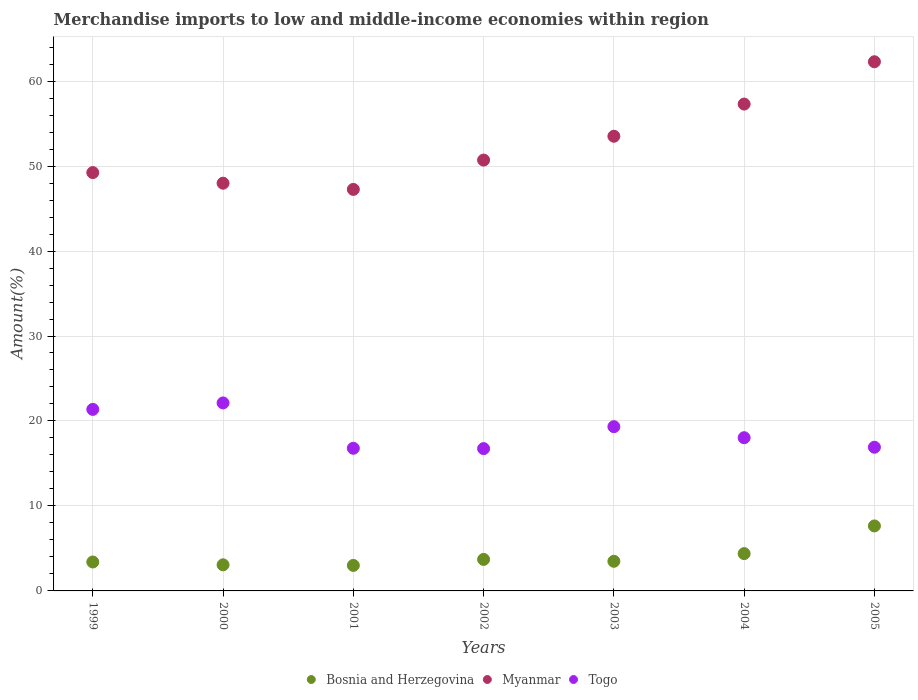How many different coloured dotlines are there?
Offer a terse response. 3. Is the number of dotlines equal to the number of legend labels?
Your response must be concise. Yes. What is the percentage of amount earned from merchandise imports in Bosnia and Herzegovina in 2000?
Give a very brief answer. 3.07. Across all years, what is the maximum percentage of amount earned from merchandise imports in Myanmar?
Give a very brief answer. 62.27. Across all years, what is the minimum percentage of amount earned from merchandise imports in Togo?
Offer a terse response. 16.75. In which year was the percentage of amount earned from merchandise imports in Bosnia and Herzegovina maximum?
Make the answer very short. 2005. In which year was the percentage of amount earned from merchandise imports in Togo minimum?
Your answer should be very brief. 2002. What is the total percentage of amount earned from merchandise imports in Togo in the graph?
Your response must be concise. 131.29. What is the difference between the percentage of amount earned from merchandise imports in Togo in 1999 and that in 2003?
Ensure brevity in your answer.  2.03. What is the difference between the percentage of amount earned from merchandise imports in Myanmar in 2004 and the percentage of amount earned from merchandise imports in Bosnia and Herzegovina in 2005?
Provide a short and direct response. 49.64. What is the average percentage of amount earned from merchandise imports in Togo per year?
Ensure brevity in your answer.  18.76. In the year 2000, what is the difference between the percentage of amount earned from merchandise imports in Myanmar and percentage of amount earned from merchandise imports in Togo?
Your answer should be compact. 25.86. In how many years, is the percentage of amount earned from merchandise imports in Togo greater than 50 %?
Give a very brief answer. 0. What is the ratio of the percentage of amount earned from merchandise imports in Bosnia and Herzegovina in 2001 to that in 2005?
Your response must be concise. 0.39. Is the percentage of amount earned from merchandise imports in Myanmar in 2000 less than that in 2002?
Offer a terse response. Yes. Is the difference between the percentage of amount earned from merchandise imports in Myanmar in 1999 and 2004 greater than the difference between the percentage of amount earned from merchandise imports in Togo in 1999 and 2004?
Give a very brief answer. No. What is the difference between the highest and the second highest percentage of amount earned from merchandise imports in Togo?
Your response must be concise. 0.76. What is the difference between the highest and the lowest percentage of amount earned from merchandise imports in Myanmar?
Your response must be concise. 15.02. Is it the case that in every year, the sum of the percentage of amount earned from merchandise imports in Bosnia and Herzegovina and percentage of amount earned from merchandise imports in Togo  is greater than the percentage of amount earned from merchandise imports in Myanmar?
Provide a succinct answer. No. Does the percentage of amount earned from merchandise imports in Togo monotonically increase over the years?
Provide a short and direct response. No. Is the percentage of amount earned from merchandise imports in Bosnia and Herzegovina strictly greater than the percentage of amount earned from merchandise imports in Myanmar over the years?
Ensure brevity in your answer.  No. Is the percentage of amount earned from merchandise imports in Bosnia and Herzegovina strictly less than the percentage of amount earned from merchandise imports in Togo over the years?
Offer a terse response. Yes. Are the values on the major ticks of Y-axis written in scientific E-notation?
Your answer should be very brief. No. Does the graph contain grids?
Keep it short and to the point. Yes. Where does the legend appear in the graph?
Provide a short and direct response. Bottom center. How are the legend labels stacked?
Provide a short and direct response. Horizontal. What is the title of the graph?
Your response must be concise. Merchandise imports to low and middle-income economies within region. What is the label or title of the X-axis?
Give a very brief answer. Years. What is the label or title of the Y-axis?
Your answer should be compact. Amount(%). What is the Amount(%) of Bosnia and Herzegovina in 1999?
Make the answer very short. 3.41. What is the Amount(%) of Myanmar in 1999?
Provide a short and direct response. 49.23. What is the Amount(%) in Togo in 1999?
Provide a succinct answer. 21.36. What is the Amount(%) of Bosnia and Herzegovina in 2000?
Keep it short and to the point. 3.07. What is the Amount(%) of Myanmar in 2000?
Give a very brief answer. 47.98. What is the Amount(%) of Togo in 2000?
Your response must be concise. 22.12. What is the Amount(%) in Bosnia and Herzegovina in 2001?
Give a very brief answer. 3. What is the Amount(%) in Myanmar in 2001?
Make the answer very short. 47.25. What is the Amount(%) of Togo in 2001?
Ensure brevity in your answer.  16.79. What is the Amount(%) in Bosnia and Herzegovina in 2002?
Keep it short and to the point. 3.71. What is the Amount(%) in Myanmar in 2002?
Make the answer very short. 50.7. What is the Amount(%) of Togo in 2002?
Keep it short and to the point. 16.75. What is the Amount(%) of Bosnia and Herzegovina in 2003?
Offer a terse response. 3.49. What is the Amount(%) of Myanmar in 2003?
Make the answer very short. 53.51. What is the Amount(%) in Togo in 2003?
Your response must be concise. 19.33. What is the Amount(%) of Bosnia and Herzegovina in 2004?
Offer a very short reply. 4.39. What is the Amount(%) of Myanmar in 2004?
Make the answer very short. 57.29. What is the Amount(%) in Togo in 2004?
Your answer should be very brief. 18.03. What is the Amount(%) in Bosnia and Herzegovina in 2005?
Provide a succinct answer. 7.65. What is the Amount(%) in Myanmar in 2005?
Make the answer very short. 62.27. What is the Amount(%) of Togo in 2005?
Ensure brevity in your answer.  16.91. Across all years, what is the maximum Amount(%) in Bosnia and Herzegovina?
Your answer should be compact. 7.65. Across all years, what is the maximum Amount(%) in Myanmar?
Make the answer very short. 62.27. Across all years, what is the maximum Amount(%) of Togo?
Provide a short and direct response. 22.12. Across all years, what is the minimum Amount(%) in Bosnia and Herzegovina?
Make the answer very short. 3. Across all years, what is the minimum Amount(%) of Myanmar?
Provide a short and direct response. 47.25. Across all years, what is the minimum Amount(%) of Togo?
Your answer should be very brief. 16.75. What is the total Amount(%) of Bosnia and Herzegovina in the graph?
Offer a terse response. 28.72. What is the total Amount(%) of Myanmar in the graph?
Ensure brevity in your answer.  368.24. What is the total Amount(%) in Togo in the graph?
Offer a very short reply. 131.29. What is the difference between the Amount(%) in Bosnia and Herzegovina in 1999 and that in 2000?
Ensure brevity in your answer.  0.34. What is the difference between the Amount(%) of Myanmar in 1999 and that in 2000?
Offer a terse response. 1.25. What is the difference between the Amount(%) of Togo in 1999 and that in 2000?
Provide a succinct answer. -0.76. What is the difference between the Amount(%) of Bosnia and Herzegovina in 1999 and that in 2001?
Offer a very short reply. 0.4. What is the difference between the Amount(%) in Myanmar in 1999 and that in 2001?
Your response must be concise. 1.98. What is the difference between the Amount(%) of Togo in 1999 and that in 2001?
Offer a terse response. 4.58. What is the difference between the Amount(%) of Bosnia and Herzegovina in 1999 and that in 2002?
Your answer should be compact. -0.3. What is the difference between the Amount(%) in Myanmar in 1999 and that in 2002?
Provide a short and direct response. -1.47. What is the difference between the Amount(%) of Togo in 1999 and that in 2002?
Make the answer very short. 4.62. What is the difference between the Amount(%) of Bosnia and Herzegovina in 1999 and that in 2003?
Offer a very short reply. -0.08. What is the difference between the Amount(%) in Myanmar in 1999 and that in 2003?
Offer a very short reply. -4.28. What is the difference between the Amount(%) of Togo in 1999 and that in 2003?
Offer a terse response. 2.03. What is the difference between the Amount(%) in Bosnia and Herzegovina in 1999 and that in 2004?
Make the answer very short. -0.99. What is the difference between the Amount(%) in Myanmar in 1999 and that in 2004?
Your answer should be compact. -8.06. What is the difference between the Amount(%) in Togo in 1999 and that in 2004?
Your answer should be very brief. 3.33. What is the difference between the Amount(%) in Bosnia and Herzegovina in 1999 and that in 2005?
Offer a very short reply. -4.24. What is the difference between the Amount(%) of Myanmar in 1999 and that in 2005?
Keep it short and to the point. -13.04. What is the difference between the Amount(%) in Togo in 1999 and that in 2005?
Offer a very short reply. 4.45. What is the difference between the Amount(%) of Bosnia and Herzegovina in 2000 and that in 2001?
Ensure brevity in your answer.  0.07. What is the difference between the Amount(%) in Myanmar in 2000 and that in 2001?
Provide a short and direct response. 0.73. What is the difference between the Amount(%) of Togo in 2000 and that in 2001?
Your answer should be very brief. 5.34. What is the difference between the Amount(%) of Bosnia and Herzegovina in 2000 and that in 2002?
Keep it short and to the point. -0.64. What is the difference between the Amount(%) in Myanmar in 2000 and that in 2002?
Your answer should be very brief. -2.72. What is the difference between the Amount(%) of Togo in 2000 and that in 2002?
Ensure brevity in your answer.  5.38. What is the difference between the Amount(%) in Bosnia and Herzegovina in 2000 and that in 2003?
Give a very brief answer. -0.42. What is the difference between the Amount(%) in Myanmar in 2000 and that in 2003?
Provide a succinct answer. -5.53. What is the difference between the Amount(%) of Togo in 2000 and that in 2003?
Provide a succinct answer. 2.79. What is the difference between the Amount(%) in Bosnia and Herzegovina in 2000 and that in 2004?
Offer a very short reply. -1.32. What is the difference between the Amount(%) in Myanmar in 2000 and that in 2004?
Your answer should be very brief. -9.31. What is the difference between the Amount(%) in Togo in 2000 and that in 2004?
Your answer should be compact. 4.09. What is the difference between the Amount(%) of Bosnia and Herzegovina in 2000 and that in 2005?
Ensure brevity in your answer.  -4.58. What is the difference between the Amount(%) in Myanmar in 2000 and that in 2005?
Your answer should be very brief. -14.29. What is the difference between the Amount(%) of Togo in 2000 and that in 2005?
Keep it short and to the point. 5.21. What is the difference between the Amount(%) in Bosnia and Herzegovina in 2001 and that in 2002?
Your answer should be compact. -0.71. What is the difference between the Amount(%) in Myanmar in 2001 and that in 2002?
Your answer should be very brief. -3.45. What is the difference between the Amount(%) of Togo in 2001 and that in 2002?
Provide a succinct answer. 0.04. What is the difference between the Amount(%) in Bosnia and Herzegovina in 2001 and that in 2003?
Provide a short and direct response. -0.48. What is the difference between the Amount(%) of Myanmar in 2001 and that in 2003?
Give a very brief answer. -6.26. What is the difference between the Amount(%) in Togo in 2001 and that in 2003?
Your answer should be very brief. -2.54. What is the difference between the Amount(%) of Bosnia and Herzegovina in 2001 and that in 2004?
Offer a terse response. -1.39. What is the difference between the Amount(%) in Myanmar in 2001 and that in 2004?
Offer a terse response. -10.04. What is the difference between the Amount(%) of Togo in 2001 and that in 2004?
Give a very brief answer. -1.24. What is the difference between the Amount(%) of Bosnia and Herzegovina in 2001 and that in 2005?
Give a very brief answer. -4.65. What is the difference between the Amount(%) in Myanmar in 2001 and that in 2005?
Your answer should be compact. -15.02. What is the difference between the Amount(%) of Togo in 2001 and that in 2005?
Give a very brief answer. -0.12. What is the difference between the Amount(%) in Bosnia and Herzegovina in 2002 and that in 2003?
Your response must be concise. 0.22. What is the difference between the Amount(%) of Myanmar in 2002 and that in 2003?
Provide a short and direct response. -2.81. What is the difference between the Amount(%) in Togo in 2002 and that in 2003?
Your answer should be very brief. -2.58. What is the difference between the Amount(%) of Bosnia and Herzegovina in 2002 and that in 2004?
Give a very brief answer. -0.68. What is the difference between the Amount(%) in Myanmar in 2002 and that in 2004?
Give a very brief answer. -6.59. What is the difference between the Amount(%) of Togo in 2002 and that in 2004?
Your response must be concise. -1.29. What is the difference between the Amount(%) in Bosnia and Herzegovina in 2002 and that in 2005?
Ensure brevity in your answer.  -3.94. What is the difference between the Amount(%) in Myanmar in 2002 and that in 2005?
Your answer should be very brief. -11.57. What is the difference between the Amount(%) of Togo in 2002 and that in 2005?
Make the answer very short. -0.16. What is the difference between the Amount(%) of Bosnia and Herzegovina in 2003 and that in 2004?
Provide a short and direct response. -0.91. What is the difference between the Amount(%) of Myanmar in 2003 and that in 2004?
Give a very brief answer. -3.79. What is the difference between the Amount(%) in Togo in 2003 and that in 2004?
Keep it short and to the point. 1.3. What is the difference between the Amount(%) of Bosnia and Herzegovina in 2003 and that in 2005?
Keep it short and to the point. -4.16. What is the difference between the Amount(%) of Myanmar in 2003 and that in 2005?
Your answer should be very brief. -8.77. What is the difference between the Amount(%) in Togo in 2003 and that in 2005?
Your response must be concise. 2.42. What is the difference between the Amount(%) of Bosnia and Herzegovina in 2004 and that in 2005?
Your answer should be very brief. -3.26. What is the difference between the Amount(%) in Myanmar in 2004 and that in 2005?
Make the answer very short. -4.98. What is the difference between the Amount(%) in Togo in 2004 and that in 2005?
Your answer should be very brief. 1.12. What is the difference between the Amount(%) of Bosnia and Herzegovina in 1999 and the Amount(%) of Myanmar in 2000?
Your answer should be compact. -44.57. What is the difference between the Amount(%) of Bosnia and Herzegovina in 1999 and the Amount(%) of Togo in 2000?
Give a very brief answer. -18.72. What is the difference between the Amount(%) in Myanmar in 1999 and the Amount(%) in Togo in 2000?
Make the answer very short. 27.11. What is the difference between the Amount(%) of Bosnia and Herzegovina in 1999 and the Amount(%) of Myanmar in 2001?
Offer a very short reply. -43.85. What is the difference between the Amount(%) of Bosnia and Herzegovina in 1999 and the Amount(%) of Togo in 2001?
Your answer should be very brief. -13.38. What is the difference between the Amount(%) of Myanmar in 1999 and the Amount(%) of Togo in 2001?
Make the answer very short. 32.44. What is the difference between the Amount(%) in Bosnia and Herzegovina in 1999 and the Amount(%) in Myanmar in 2002?
Keep it short and to the point. -47.3. What is the difference between the Amount(%) in Bosnia and Herzegovina in 1999 and the Amount(%) in Togo in 2002?
Offer a terse response. -13.34. What is the difference between the Amount(%) in Myanmar in 1999 and the Amount(%) in Togo in 2002?
Offer a terse response. 32.48. What is the difference between the Amount(%) of Bosnia and Herzegovina in 1999 and the Amount(%) of Myanmar in 2003?
Make the answer very short. -50.1. What is the difference between the Amount(%) of Bosnia and Herzegovina in 1999 and the Amount(%) of Togo in 2003?
Your response must be concise. -15.92. What is the difference between the Amount(%) in Myanmar in 1999 and the Amount(%) in Togo in 2003?
Your response must be concise. 29.9. What is the difference between the Amount(%) in Bosnia and Herzegovina in 1999 and the Amount(%) in Myanmar in 2004?
Your answer should be compact. -53.89. What is the difference between the Amount(%) of Bosnia and Herzegovina in 1999 and the Amount(%) of Togo in 2004?
Your response must be concise. -14.63. What is the difference between the Amount(%) in Myanmar in 1999 and the Amount(%) in Togo in 2004?
Provide a succinct answer. 31.2. What is the difference between the Amount(%) in Bosnia and Herzegovina in 1999 and the Amount(%) in Myanmar in 2005?
Ensure brevity in your answer.  -58.87. What is the difference between the Amount(%) of Bosnia and Herzegovina in 1999 and the Amount(%) of Togo in 2005?
Offer a very short reply. -13.5. What is the difference between the Amount(%) of Myanmar in 1999 and the Amount(%) of Togo in 2005?
Your answer should be compact. 32.32. What is the difference between the Amount(%) of Bosnia and Herzegovina in 2000 and the Amount(%) of Myanmar in 2001?
Offer a very short reply. -44.18. What is the difference between the Amount(%) of Bosnia and Herzegovina in 2000 and the Amount(%) of Togo in 2001?
Your answer should be compact. -13.72. What is the difference between the Amount(%) of Myanmar in 2000 and the Amount(%) of Togo in 2001?
Ensure brevity in your answer.  31.19. What is the difference between the Amount(%) of Bosnia and Herzegovina in 2000 and the Amount(%) of Myanmar in 2002?
Provide a short and direct response. -47.63. What is the difference between the Amount(%) of Bosnia and Herzegovina in 2000 and the Amount(%) of Togo in 2002?
Provide a short and direct response. -13.68. What is the difference between the Amount(%) in Myanmar in 2000 and the Amount(%) in Togo in 2002?
Provide a succinct answer. 31.23. What is the difference between the Amount(%) in Bosnia and Herzegovina in 2000 and the Amount(%) in Myanmar in 2003?
Give a very brief answer. -50.44. What is the difference between the Amount(%) in Bosnia and Herzegovina in 2000 and the Amount(%) in Togo in 2003?
Provide a short and direct response. -16.26. What is the difference between the Amount(%) in Myanmar in 2000 and the Amount(%) in Togo in 2003?
Your answer should be very brief. 28.65. What is the difference between the Amount(%) in Bosnia and Herzegovina in 2000 and the Amount(%) in Myanmar in 2004?
Offer a very short reply. -54.22. What is the difference between the Amount(%) of Bosnia and Herzegovina in 2000 and the Amount(%) of Togo in 2004?
Give a very brief answer. -14.96. What is the difference between the Amount(%) of Myanmar in 2000 and the Amount(%) of Togo in 2004?
Give a very brief answer. 29.95. What is the difference between the Amount(%) of Bosnia and Herzegovina in 2000 and the Amount(%) of Myanmar in 2005?
Offer a very short reply. -59.2. What is the difference between the Amount(%) of Bosnia and Herzegovina in 2000 and the Amount(%) of Togo in 2005?
Keep it short and to the point. -13.84. What is the difference between the Amount(%) of Myanmar in 2000 and the Amount(%) of Togo in 2005?
Your answer should be very brief. 31.07. What is the difference between the Amount(%) of Bosnia and Herzegovina in 2001 and the Amount(%) of Myanmar in 2002?
Ensure brevity in your answer.  -47.7. What is the difference between the Amount(%) of Bosnia and Herzegovina in 2001 and the Amount(%) of Togo in 2002?
Ensure brevity in your answer.  -13.74. What is the difference between the Amount(%) of Myanmar in 2001 and the Amount(%) of Togo in 2002?
Offer a terse response. 30.51. What is the difference between the Amount(%) of Bosnia and Herzegovina in 2001 and the Amount(%) of Myanmar in 2003?
Your answer should be very brief. -50.51. What is the difference between the Amount(%) of Bosnia and Herzegovina in 2001 and the Amount(%) of Togo in 2003?
Your answer should be compact. -16.33. What is the difference between the Amount(%) of Myanmar in 2001 and the Amount(%) of Togo in 2003?
Give a very brief answer. 27.92. What is the difference between the Amount(%) of Bosnia and Herzegovina in 2001 and the Amount(%) of Myanmar in 2004?
Your response must be concise. -54.29. What is the difference between the Amount(%) of Bosnia and Herzegovina in 2001 and the Amount(%) of Togo in 2004?
Keep it short and to the point. -15.03. What is the difference between the Amount(%) of Myanmar in 2001 and the Amount(%) of Togo in 2004?
Your answer should be compact. 29.22. What is the difference between the Amount(%) in Bosnia and Herzegovina in 2001 and the Amount(%) in Myanmar in 2005?
Provide a short and direct response. -59.27. What is the difference between the Amount(%) of Bosnia and Herzegovina in 2001 and the Amount(%) of Togo in 2005?
Ensure brevity in your answer.  -13.91. What is the difference between the Amount(%) of Myanmar in 2001 and the Amount(%) of Togo in 2005?
Your answer should be compact. 30.34. What is the difference between the Amount(%) in Bosnia and Herzegovina in 2002 and the Amount(%) in Myanmar in 2003?
Provide a succinct answer. -49.8. What is the difference between the Amount(%) in Bosnia and Herzegovina in 2002 and the Amount(%) in Togo in 2003?
Provide a succinct answer. -15.62. What is the difference between the Amount(%) of Myanmar in 2002 and the Amount(%) of Togo in 2003?
Offer a very short reply. 31.37. What is the difference between the Amount(%) in Bosnia and Herzegovina in 2002 and the Amount(%) in Myanmar in 2004?
Make the answer very short. -53.58. What is the difference between the Amount(%) in Bosnia and Herzegovina in 2002 and the Amount(%) in Togo in 2004?
Your response must be concise. -14.32. What is the difference between the Amount(%) in Myanmar in 2002 and the Amount(%) in Togo in 2004?
Keep it short and to the point. 32.67. What is the difference between the Amount(%) in Bosnia and Herzegovina in 2002 and the Amount(%) in Myanmar in 2005?
Your answer should be compact. -58.56. What is the difference between the Amount(%) of Bosnia and Herzegovina in 2002 and the Amount(%) of Togo in 2005?
Give a very brief answer. -13.2. What is the difference between the Amount(%) in Myanmar in 2002 and the Amount(%) in Togo in 2005?
Your answer should be compact. 33.79. What is the difference between the Amount(%) in Bosnia and Herzegovina in 2003 and the Amount(%) in Myanmar in 2004?
Your response must be concise. -53.81. What is the difference between the Amount(%) in Bosnia and Herzegovina in 2003 and the Amount(%) in Togo in 2004?
Offer a terse response. -14.55. What is the difference between the Amount(%) in Myanmar in 2003 and the Amount(%) in Togo in 2004?
Provide a succinct answer. 35.48. What is the difference between the Amount(%) of Bosnia and Herzegovina in 2003 and the Amount(%) of Myanmar in 2005?
Offer a terse response. -58.79. What is the difference between the Amount(%) of Bosnia and Herzegovina in 2003 and the Amount(%) of Togo in 2005?
Provide a succinct answer. -13.42. What is the difference between the Amount(%) in Myanmar in 2003 and the Amount(%) in Togo in 2005?
Offer a very short reply. 36.6. What is the difference between the Amount(%) in Bosnia and Herzegovina in 2004 and the Amount(%) in Myanmar in 2005?
Provide a succinct answer. -57.88. What is the difference between the Amount(%) in Bosnia and Herzegovina in 2004 and the Amount(%) in Togo in 2005?
Your answer should be compact. -12.52. What is the difference between the Amount(%) of Myanmar in 2004 and the Amount(%) of Togo in 2005?
Your answer should be compact. 40.38. What is the average Amount(%) of Bosnia and Herzegovina per year?
Ensure brevity in your answer.  4.1. What is the average Amount(%) of Myanmar per year?
Provide a short and direct response. 52.61. What is the average Amount(%) in Togo per year?
Provide a succinct answer. 18.76. In the year 1999, what is the difference between the Amount(%) of Bosnia and Herzegovina and Amount(%) of Myanmar?
Your response must be concise. -45.82. In the year 1999, what is the difference between the Amount(%) of Bosnia and Herzegovina and Amount(%) of Togo?
Make the answer very short. -17.96. In the year 1999, what is the difference between the Amount(%) of Myanmar and Amount(%) of Togo?
Provide a short and direct response. 27.87. In the year 2000, what is the difference between the Amount(%) in Bosnia and Herzegovina and Amount(%) in Myanmar?
Provide a succinct answer. -44.91. In the year 2000, what is the difference between the Amount(%) of Bosnia and Herzegovina and Amount(%) of Togo?
Offer a very short reply. -19.05. In the year 2000, what is the difference between the Amount(%) of Myanmar and Amount(%) of Togo?
Your answer should be compact. 25.86. In the year 2001, what is the difference between the Amount(%) of Bosnia and Herzegovina and Amount(%) of Myanmar?
Provide a succinct answer. -44.25. In the year 2001, what is the difference between the Amount(%) of Bosnia and Herzegovina and Amount(%) of Togo?
Provide a short and direct response. -13.78. In the year 2001, what is the difference between the Amount(%) in Myanmar and Amount(%) in Togo?
Make the answer very short. 30.46. In the year 2002, what is the difference between the Amount(%) of Bosnia and Herzegovina and Amount(%) of Myanmar?
Offer a terse response. -46.99. In the year 2002, what is the difference between the Amount(%) of Bosnia and Herzegovina and Amount(%) of Togo?
Offer a terse response. -13.04. In the year 2002, what is the difference between the Amount(%) in Myanmar and Amount(%) in Togo?
Provide a short and direct response. 33.96. In the year 2003, what is the difference between the Amount(%) in Bosnia and Herzegovina and Amount(%) in Myanmar?
Your response must be concise. -50.02. In the year 2003, what is the difference between the Amount(%) in Bosnia and Herzegovina and Amount(%) in Togo?
Ensure brevity in your answer.  -15.84. In the year 2003, what is the difference between the Amount(%) of Myanmar and Amount(%) of Togo?
Provide a succinct answer. 34.18. In the year 2004, what is the difference between the Amount(%) in Bosnia and Herzegovina and Amount(%) in Myanmar?
Make the answer very short. -52.9. In the year 2004, what is the difference between the Amount(%) of Bosnia and Herzegovina and Amount(%) of Togo?
Give a very brief answer. -13.64. In the year 2004, what is the difference between the Amount(%) in Myanmar and Amount(%) in Togo?
Provide a succinct answer. 39.26. In the year 2005, what is the difference between the Amount(%) of Bosnia and Herzegovina and Amount(%) of Myanmar?
Make the answer very short. -54.62. In the year 2005, what is the difference between the Amount(%) of Bosnia and Herzegovina and Amount(%) of Togo?
Your answer should be compact. -9.26. In the year 2005, what is the difference between the Amount(%) of Myanmar and Amount(%) of Togo?
Your answer should be very brief. 45.37. What is the ratio of the Amount(%) of Bosnia and Herzegovina in 1999 to that in 2000?
Provide a short and direct response. 1.11. What is the ratio of the Amount(%) in Myanmar in 1999 to that in 2000?
Offer a very short reply. 1.03. What is the ratio of the Amount(%) in Togo in 1999 to that in 2000?
Your answer should be very brief. 0.97. What is the ratio of the Amount(%) in Bosnia and Herzegovina in 1999 to that in 2001?
Provide a short and direct response. 1.13. What is the ratio of the Amount(%) in Myanmar in 1999 to that in 2001?
Offer a very short reply. 1.04. What is the ratio of the Amount(%) in Togo in 1999 to that in 2001?
Keep it short and to the point. 1.27. What is the ratio of the Amount(%) of Bosnia and Herzegovina in 1999 to that in 2002?
Provide a short and direct response. 0.92. What is the ratio of the Amount(%) of Myanmar in 1999 to that in 2002?
Your response must be concise. 0.97. What is the ratio of the Amount(%) of Togo in 1999 to that in 2002?
Your answer should be compact. 1.28. What is the ratio of the Amount(%) of Bosnia and Herzegovina in 1999 to that in 2003?
Ensure brevity in your answer.  0.98. What is the ratio of the Amount(%) of Myanmar in 1999 to that in 2003?
Provide a short and direct response. 0.92. What is the ratio of the Amount(%) in Togo in 1999 to that in 2003?
Your response must be concise. 1.11. What is the ratio of the Amount(%) of Bosnia and Herzegovina in 1999 to that in 2004?
Make the answer very short. 0.78. What is the ratio of the Amount(%) of Myanmar in 1999 to that in 2004?
Ensure brevity in your answer.  0.86. What is the ratio of the Amount(%) of Togo in 1999 to that in 2004?
Your answer should be compact. 1.18. What is the ratio of the Amount(%) in Bosnia and Herzegovina in 1999 to that in 2005?
Your answer should be compact. 0.45. What is the ratio of the Amount(%) of Myanmar in 1999 to that in 2005?
Ensure brevity in your answer.  0.79. What is the ratio of the Amount(%) in Togo in 1999 to that in 2005?
Offer a very short reply. 1.26. What is the ratio of the Amount(%) of Bosnia and Herzegovina in 2000 to that in 2001?
Offer a very short reply. 1.02. What is the ratio of the Amount(%) in Myanmar in 2000 to that in 2001?
Your answer should be very brief. 1.02. What is the ratio of the Amount(%) in Togo in 2000 to that in 2001?
Your response must be concise. 1.32. What is the ratio of the Amount(%) of Bosnia and Herzegovina in 2000 to that in 2002?
Provide a short and direct response. 0.83. What is the ratio of the Amount(%) of Myanmar in 2000 to that in 2002?
Your answer should be compact. 0.95. What is the ratio of the Amount(%) of Togo in 2000 to that in 2002?
Provide a short and direct response. 1.32. What is the ratio of the Amount(%) in Bosnia and Herzegovina in 2000 to that in 2003?
Your answer should be compact. 0.88. What is the ratio of the Amount(%) in Myanmar in 2000 to that in 2003?
Your answer should be compact. 0.9. What is the ratio of the Amount(%) of Togo in 2000 to that in 2003?
Your answer should be compact. 1.14. What is the ratio of the Amount(%) of Bosnia and Herzegovina in 2000 to that in 2004?
Provide a succinct answer. 0.7. What is the ratio of the Amount(%) of Myanmar in 2000 to that in 2004?
Offer a very short reply. 0.84. What is the ratio of the Amount(%) in Togo in 2000 to that in 2004?
Keep it short and to the point. 1.23. What is the ratio of the Amount(%) of Bosnia and Herzegovina in 2000 to that in 2005?
Ensure brevity in your answer.  0.4. What is the ratio of the Amount(%) in Myanmar in 2000 to that in 2005?
Make the answer very short. 0.77. What is the ratio of the Amount(%) of Togo in 2000 to that in 2005?
Provide a short and direct response. 1.31. What is the ratio of the Amount(%) in Bosnia and Herzegovina in 2001 to that in 2002?
Give a very brief answer. 0.81. What is the ratio of the Amount(%) in Myanmar in 2001 to that in 2002?
Provide a succinct answer. 0.93. What is the ratio of the Amount(%) in Togo in 2001 to that in 2002?
Your answer should be compact. 1. What is the ratio of the Amount(%) of Bosnia and Herzegovina in 2001 to that in 2003?
Provide a short and direct response. 0.86. What is the ratio of the Amount(%) in Myanmar in 2001 to that in 2003?
Make the answer very short. 0.88. What is the ratio of the Amount(%) of Togo in 2001 to that in 2003?
Keep it short and to the point. 0.87. What is the ratio of the Amount(%) of Bosnia and Herzegovina in 2001 to that in 2004?
Offer a very short reply. 0.68. What is the ratio of the Amount(%) in Myanmar in 2001 to that in 2004?
Keep it short and to the point. 0.82. What is the ratio of the Amount(%) in Togo in 2001 to that in 2004?
Provide a short and direct response. 0.93. What is the ratio of the Amount(%) in Bosnia and Herzegovina in 2001 to that in 2005?
Offer a terse response. 0.39. What is the ratio of the Amount(%) of Myanmar in 2001 to that in 2005?
Provide a succinct answer. 0.76. What is the ratio of the Amount(%) in Togo in 2001 to that in 2005?
Provide a short and direct response. 0.99. What is the ratio of the Amount(%) of Bosnia and Herzegovina in 2002 to that in 2003?
Offer a very short reply. 1.06. What is the ratio of the Amount(%) in Myanmar in 2002 to that in 2003?
Your answer should be compact. 0.95. What is the ratio of the Amount(%) in Togo in 2002 to that in 2003?
Provide a succinct answer. 0.87. What is the ratio of the Amount(%) in Bosnia and Herzegovina in 2002 to that in 2004?
Ensure brevity in your answer.  0.84. What is the ratio of the Amount(%) in Myanmar in 2002 to that in 2004?
Provide a short and direct response. 0.89. What is the ratio of the Amount(%) in Togo in 2002 to that in 2004?
Provide a succinct answer. 0.93. What is the ratio of the Amount(%) of Bosnia and Herzegovina in 2002 to that in 2005?
Make the answer very short. 0.48. What is the ratio of the Amount(%) of Myanmar in 2002 to that in 2005?
Offer a terse response. 0.81. What is the ratio of the Amount(%) in Togo in 2002 to that in 2005?
Provide a short and direct response. 0.99. What is the ratio of the Amount(%) of Bosnia and Herzegovina in 2003 to that in 2004?
Your response must be concise. 0.79. What is the ratio of the Amount(%) of Myanmar in 2003 to that in 2004?
Offer a very short reply. 0.93. What is the ratio of the Amount(%) of Togo in 2003 to that in 2004?
Provide a short and direct response. 1.07. What is the ratio of the Amount(%) of Bosnia and Herzegovina in 2003 to that in 2005?
Ensure brevity in your answer.  0.46. What is the ratio of the Amount(%) of Myanmar in 2003 to that in 2005?
Offer a very short reply. 0.86. What is the ratio of the Amount(%) in Togo in 2003 to that in 2005?
Offer a terse response. 1.14. What is the ratio of the Amount(%) in Bosnia and Herzegovina in 2004 to that in 2005?
Offer a terse response. 0.57. What is the ratio of the Amount(%) of Myanmar in 2004 to that in 2005?
Offer a terse response. 0.92. What is the ratio of the Amount(%) in Togo in 2004 to that in 2005?
Give a very brief answer. 1.07. What is the difference between the highest and the second highest Amount(%) of Bosnia and Herzegovina?
Provide a succinct answer. 3.26. What is the difference between the highest and the second highest Amount(%) in Myanmar?
Offer a very short reply. 4.98. What is the difference between the highest and the second highest Amount(%) in Togo?
Offer a terse response. 0.76. What is the difference between the highest and the lowest Amount(%) of Bosnia and Herzegovina?
Your answer should be very brief. 4.65. What is the difference between the highest and the lowest Amount(%) of Myanmar?
Your answer should be very brief. 15.02. What is the difference between the highest and the lowest Amount(%) of Togo?
Give a very brief answer. 5.38. 